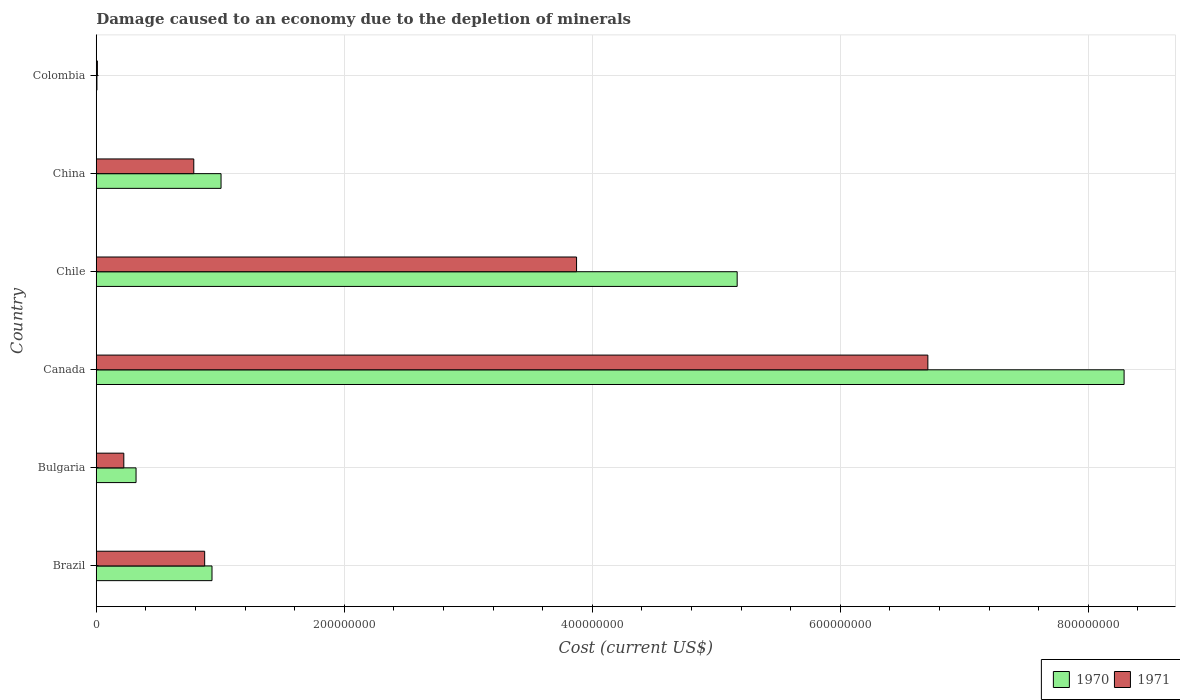How many groups of bars are there?
Your response must be concise. 6. Are the number of bars per tick equal to the number of legend labels?
Keep it short and to the point. Yes. How many bars are there on the 3rd tick from the top?
Your answer should be compact. 2. What is the label of the 3rd group of bars from the top?
Keep it short and to the point. Chile. In how many cases, is the number of bars for a given country not equal to the number of legend labels?
Keep it short and to the point. 0. What is the cost of damage caused due to the depletion of minerals in 1970 in Colombia?
Provide a short and direct response. 5.53e+05. Across all countries, what is the maximum cost of damage caused due to the depletion of minerals in 1971?
Ensure brevity in your answer.  6.71e+08. Across all countries, what is the minimum cost of damage caused due to the depletion of minerals in 1970?
Offer a terse response. 5.53e+05. What is the total cost of damage caused due to the depletion of minerals in 1971 in the graph?
Keep it short and to the point. 1.25e+09. What is the difference between the cost of damage caused due to the depletion of minerals in 1971 in Bulgaria and that in Colombia?
Your response must be concise. 2.13e+07. What is the difference between the cost of damage caused due to the depletion of minerals in 1970 in Chile and the cost of damage caused due to the depletion of minerals in 1971 in Canada?
Your answer should be compact. -1.54e+08. What is the average cost of damage caused due to the depletion of minerals in 1970 per country?
Provide a succinct answer. 2.62e+08. What is the difference between the cost of damage caused due to the depletion of minerals in 1971 and cost of damage caused due to the depletion of minerals in 1970 in Chile?
Make the answer very short. -1.30e+08. What is the ratio of the cost of damage caused due to the depletion of minerals in 1971 in Brazil to that in Bulgaria?
Offer a terse response. 3.94. Is the cost of damage caused due to the depletion of minerals in 1970 in Canada less than that in Chile?
Provide a succinct answer. No. Is the difference between the cost of damage caused due to the depletion of minerals in 1971 in Brazil and Canada greater than the difference between the cost of damage caused due to the depletion of minerals in 1970 in Brazil and Canada?
Your response must be concise. Yes. What is the difference between the highest and the second highest cost of damage caused due to the depletion of minerals in 1970?
Keep it short and to the point. 3.12e+08. What is the difference between the highest and the lowest cost of damage caused due to the depletion of minerals in 1971?
Your response must be concise. 6.70e+08. What does the 1st bar from the top in Chile represents?
Your answer should be compact. 1971. How many bars are there?
Your answer should be very brief. 12. Are the values on the major ticks of X-axis written in scientific E-notation?
Your answer should be very brief. No. Does the graph contain grids?
Offer a terse response. Yes. Where does the legend appear in the graph?
Keep it short and to the point. Bottom right. How are the legend labels stacked?
Your answer should be compact. Horizontal. What is the title of the graph?
Make the answer very short. Damage caused to an economy due to the depletion of minerals. What is the label or title of the X-axis?
Keep it short and to the point. Cost (current US$). What is the label or title of the Y-axis?
Your answer should be very brief. Country. What is the Cost (current US$) in 1970 in Brazil?
Your answer should be compact. 9.33e+07. What is the Cost (current US$) of 1971 in Brazil?
Provide a short and direct response. 8.74e+07. What is the Cost (current US$) in 1970 in Bulgaria?
Keep it short and to the point. 3.21e+07. What is the Cost (current US$) of 1971 in Bulgaria?
Your response must be concise. 2.22e+07. What is the Cost (current US$) of 1970 in Canada?
Give a very brief answer. 8.29e+08. What is the Cost (current US$) of 1971 in Canada?
Provide a short and direct response. 6.71e+08. What is the Cost (current US$) in 1970 in Chile?
Provide a short and direct response. 5.17e+08. What is the Cost (current US$) in 1971 in Chile?
Keep it short and to the point. 3.87e+08. What is the Cost (current US$) of 1970 in China?
Make the answer very short. 1.01e+08. What is the Cost (current US$) in 1971 in China?
Offer a terse response. 7.87e+07. What is the Cost (current US$) of 1970 in Colombia?
Keep it short and to the point. 5.53e+05. What is the Cost (current US$) in 1971 in Colombia?
Provide a short and direct response. 9.12e+05. Across all countries, what is the maximum Cost (current US$) in 1970?
Make the answer very short. 8.29e+08. Across all countries, what is the maximum Cost (current US$) of 1971?
Your response must be concise. 6.71e+08. Across all countries, what is the minimum Cost (current US$) of 1970?
Give a very brief answer. 5.53e+05. Across all countries, what is the minimum Cost (current US$) of 1971?
Offer a terse response. 9.12e+05. What is the total Cost (current US$) of 1970 in the graph?
Make the answer very short. 1.57e+09. What is the total Cost (current US$) of 1971 in the graph?
Your answer should be very brief. 1.25e+09. What is the difference between the Cost (current US$) in 1970 in Brazil and that in Bulgaria?
Provide a short and direct response. 6.12e+07. What is the difference between the Cost (current US$) in 1971 in Brazil and that in Bulgaria?
Provide a short and direct response. 6.52e+07. What is the difference between the Cost (current US$) in 1970 in Brazil and that in Canada?
Your answer should be very brief. -7.36e+08. What is the difference between the Cost (current US$) of 1971 in Brazil and that in Canada?
Give a very brief answer. -5.83e+08. What is the difference between the Cost (current US$) of 1970 in Brazil and that in Chile?
Provide a succinct answer. -4.24e+08. What is the difference between the Cost (current US$) in 1971 in Brazil and that in Chile?
Keep it short and to the point. -3.00e+08. What is the difference between the Cost (current US$) in 1970 in Brazil and that in China?
Keep it short and to the point. -7.30e+06. What is the difference between the Cost (current US$) of 1971 in Brazil and that in China?
Provide a succinct answer. 8.78e+06. What is the difference between the Cost (current US$) of 1970 in Brazil and that in Colombia?
Make the answer very short. 9.28e+07. What is the difference between the Cost (current US$) in 1971 in Brazil and that in Colombia?
Provide a succinct answer. 8.65e+07. What is the difference between the Cost (current US$) of 1970 in Bulgaria and that in Canada?
Provide a short and direct response. -7.97e+08. What is the difference between the Cost (current US$) of 1971 in Bulgaria and that in Canada?
Ensure brevity in your answer.  -6.48e+08. What is the difference between the Cost (current US$) in 1970 in Bulgaria and that in Chile?
Keep it short and to the point. -4.85e+08. What is the difference between the Cost (current US$) in 1971 in Bulgaria and that in Chile?
Your answer should be very brief. -3.65e+08. What is the difference between the Cost (current US$) of 1970 in Bulgaria and that in China?
Your answer should be compact. -6.85e+07. What is the difference between the Cost (current US$) of 1971 in Bulgaria and that in China?
Offer a very short reply. -5.64e+07. What is the difference between the Cost (current US$) of 1970 in Bulgaria and that in Colombia?
Give a very brief answer. 3.15e+07. What is the difference between the Cost (current US$) in 1971 in Bulgaria and that in Colombia?
Offer a terse response. 2.13e+07. What is the difference between the Cost (current US$) of 1970 in Canada and that in Chile?
Offer a terse response. 3.12e+08. What is the difference between the Cost (current US$) of 1971 in Canada and that in Chile?
Provide a short and direct response. 2.83e+08. What is the difference between the Cost (current US$) in 1970 in Canada and that in China?
Ensure brevity in your answer.  7.28e+08. What is the difference between the Cost (current US$) of 1971 in Canada and that in China?
Your response must be concise. 5.92e+08. What is the difference between the Cost (current US$) of 1970 in Canada and that in Colombia?
Offer a very short reply. 8.28e+08. What is the difference between the Cost (current US$) in 1971 in Canada and that in Colombia?
Your answer should be very brief. 6.70e+08. What is the difference between the Cost (current US$) in 1970 in Chile and that in China?
Your response must be concise. 4.16e+08. What is the difference between the Cost (current US$) in 1971 in Chile and that in China?
Provide a succinct answer. 3.09e+08. What is the difference between the Cost (current US$) in 1970 in Chile and that in Colombia?
Your answer should be very brief. 5.16e+08. What is the difference between the Cost (current US$) in 1971 in Chile and that in Colombia?
Ensure brevity in your answer.  3.86e+08. What is the difference between the Cost (current US$) in 1970 in China and that in Colombia?
Ensure brevity in your answer.  1.00e+08. What is the difference between the Cost (current US$) of 1971 in China and that in Colombia?
Your answer should be very brief. 7.77e+07. What is the difference between the Cost (current US$) of 1970 in Brazil and the Cost (current US$) of 1971 in Bulgaria?
Your answer should be compact. 7.11e+07. What is the difference between the Cost (current US$) of 1970 in Brazil and the Cost (current US$) of 1971 in Canada?
Provide a short and direct response. -5.77e+08. What is the difference between the Cost (current US$) in 1970 in Brazil and the Cost (current US$) in 1971 in Chile?
Ensure brevity in your answer.  -2.94e+08. What is the difference between the Cost (current US$) in 1970 in Brazil and the Cost (current US$) in 1971 in China?
Offer a very short reply. 1.47e+07. What is the difference between the Cost (current US$) in 1970 in Brazil and the Cost (current US$) in 1971 in Colombia?
Provide a succinct answer. 9.24e+07. What is the difference between the Cost (current US$) in 1970 in Bulgaria and the Cost (current US$) in 1971 in Canada?
Offer a very short reply. -6.39e+08. What is the difference between the Cost (current US$) in 1970 in Bulgaria and the Cost (current US$) in 1971 in Chile?
Your response must be concise. -3.55e+08. What is the difference between the Cost (current US$) in 1970 in Bulgaria and the Cost (current US$) in 1971 in China?
Provide a succinct answer. -4.66e+07. What is the difference between the Cost (current US$) of 1970 in Bulgaria and the Cost (current US$) of 1971 in Colombia?
Offer a terse response. 3.12e+07. What is the difference between the Cost (current US$) of 1970 in Canada and the Cost (current US$) of 1971 in Chile?
Make the answer very short. 4.42e+08. What is the difference between the Cost (current US$) in 1970 in Canada and the Cost (current US$) in 1971 in China?
Your response must be concise. 7.50e+08. What is the difference between the Cost (current US$) in 1970 in Canada and the Cost (current US$) in 1971 in Colombia?
Give a very brief answer. 8.28e+08. What is the difference between the Cost (current US$) of 1970 in Chile and the Cost (current US$) of 1971 in China?
Your answer should be compact. 4.38e+08. What is the difference between the Cost (current US$) of 1970 in Chile and the Cost (current US$) of 1971 in Colombia?
Provide a short and direct response. 5.16e+08. What is the difference between the Cost (current US$) of 1970 in China and the Cost (current US$) of 1971 in Colombia?
Your answer should be very brief. 9.97e+07. What is the average Cost (current US$) of 1970 per country?
Give a very brief answer. 2.62e+08. What is the average Cost (current US$) in 1971 per country?
Offer a very short reply. 2.08e+08. What is the difference between the Cost (current US$) in 1970 and Cost (current US$) in 1971 in Brazil?
Ensure brevity in your answer.  5.90e+06. What is the difference between the Cost (current US$) of 1970 and Cost (current US$) of 1971 in Bulgaria?
Your response must be concise. 9.88e+06. What is the difference between the Cost (current US$) of 1970 and Cost (current US$) of 1971 in Canada?
Give a very brief answer. 1.58e+08. What is the difference between the Cost (current US$) of 1970 and Cost (current US$) of 1971 in Chile?
Offer a terse response. 1.30e+08. What is the difference between the Cost (current US$) in 1970 and Cost (current US$) in 1971 in China?
Offer a terse response. 2.20e+07. What is the difference between the Cost (current US$) in 1970 and Cost (current US$) in 1971 in Colombia?
Ensure brevity in your answer.  -3.59e+05. What is the ratio of the Cost (current US$) in 1970 in Brazil to that in Bulgaria?
Keep it short and to the point. 2.91. What is the ratio of the Cost (current US$) in 1971 in Brazil to that in Bulgaria?
Your answer should be compact. 3.94. What is the ratio of the Cost (current US$) in 1970 in Brazil to that in Canada?
Offer a very short reply. 0.11. What is the ratio of the Cost (current US$) in 1971 in Brazil to that in Canada?
Your response must be concise. 0.13. What is the ratio of the Cost (current US$) in 1970 in Brazil to that in Chile?
Your answer should be very brief. 0.18. What is the ratio of the Cost (current US$) in 1971 in Brazil to that in Chile?
Make the answer very short. 0.23. What is the ratio of the Cost (current US$) in 1970 in Brazil to that in China?
Provide a short and direct response. 0.93. What is the ratio of the Cost (current US$) in 1971 in Brazil to that in China?
Keep it short and to the point. 1.11. What is the ratio of the Cost (current US$) of 1970 in Brazil to that in Colombia?
Your response must be concise. 168.9. What is the ratio of the Cost (current US$) in 1971 in Brazil to that in Colombia?
Make the answer very short. 95.87. What is the ratio of the Cost (current US$) in 1970 in Bulgaria to that in Canada?
Ensure brevity in your answer.  0.04. What is the ratio of the Cost (current US$) in 1971 in Bulgaria to that in Canada?
Your answer should be compact. 0.03. What is the ratio of the Cost (current US$) of 1970 in Bulgaria to that in Chile?
Keep it short and to the point. 0.06. What is the ratio of the Cost (current US$) of 1971 in Bulgaria to that in Chile?
Keep it short and to the point. 0.06. What is the ratio of the Cost (current US$) in 1970 in Bulgaria to that in China?
Your answer should be compact. 0.32. What is the ratio of the Cost (current US$) in 1971 in Bulgaria to that in China?
Your answer should be compact. 0.28. What is the ratio of the Cost (current US$) in 1970 in Bulgaria to that in Colombia?
Your response must be concise. 58.07. What is the ratio of the Cost (current US$) in 1971 in Bulgaria to that in Colombia?
Make the answer very short. 24.36. What is the ratio of the Cost (current US$) of 1970 in Canada to that in Chile?
Provide a succinct answer. 1.6. What is the ratio of the Cost (current US$) in 1971 in Canada to that in Chile?
Your answer should be very brief. 1.73. What is the ratio of the Cost (current US$) of 1970 in Canada to that in China?
Your answer should be very brief. 8.24. What is the ratio of the Cost (current US$) of 1971 in Canada to that in China?
Give a very brief answer. 8.53. What is the ratio of the Cost (current US$) of 1970 in Canada to that in Colombia?
Provide a short and direct response. 1500.08. What is the ratio of the Cost (current US$) of 1971 in Canada to that in Colombia?
Offer a very short reply. 735.38. What is the ratio of the Cost (current US$) in 1970 in Chile to that in China?
Offer a very short reply. 5.14. What is the ratio of the Cost (current US$) of 1971 in Chile to that in China?
Provide a short and direct response. 4.92. What is the ratio of the Cost (current US$) of 1970 in Chile to that in Colombia?
Your answer should be very brief. 935.39. What is the ratio of the Cost (current US$) in 1971 in Chile to that in Colombia?
Your answer should be very brief. 424.73. What is the ratio of the Cost (current US$) of 1970 in China to that in Colombia?
Keep it short and to the point. 182.11. What is the ratio of the Cost (current US$) of 1971 in China to that in Colombia?
Offer a very short reply. 86.24. What is the difference between the highest and the second highest Cost (current US$) of 1970?
Your response must be concise. 3.12e+08. What is the difference between the highest and the second highest Cost (current US$) in 1971?
Your answer should be compact. 2.83e+08. What is the difference between the highest and the lowest Cost (current US$) in 1970?
Offer a terse response. 8.28e+08. What is the difference between the highest and the lowest Cost (current US$) of 1971?
Provide a succinct answer. 6.70e+08. 